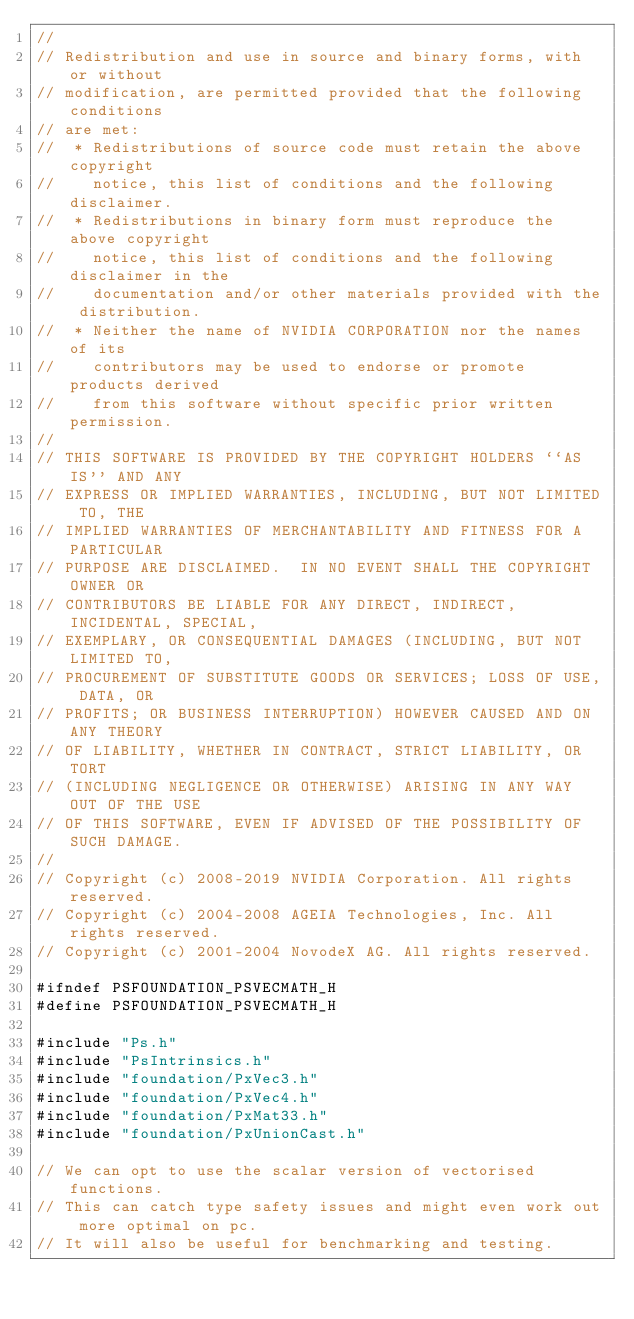Convert code to text. <code><loc_0><loc_0><loc_500><loc_500><_C_>//
// Redistribution and use in source and binary forms, with or without
// modification, are permitted provided that the following conditions
// are met:
//  * Redistributions of source code must retain the above copyright
//    notice, this list of conditions and the following disclaimer.
//  * Redistributions in binary form must reproduce the above copyright
//    notice, this list of conditions and the following disclaimer in the
//    documentation and/or other materials provided with the distribution.
//  * Neither the name of NVIDIA CORPORATION nor the names of its
//    contributors may be used to endorse or promote products derived
//    from this software without specific prior written permission.
//
// THIS SOFTWARE IS PROVIDED BY THE COPYRIGHT HOLDERS ``AS IS'' AND ANY
// EXPRESS OR IMPLIED WARRANTIES, INCLUDING, BUT NOT LIMITED TO, THE
// IMPLIED WARRANTIES OF MERCHANTABILITY AND FITNESS FOR A PARTICULAR
// PURPOSE ARE DISCLAIMED.  IN NO EVENT SHALL THE COPYRIGHT OWNER OR
// CONTRIBUTORS BE LIABLE FOR ANY DIRECT, INDIRECT, INCIDENTAL, SPECIAL,
// EXEMPLARY, OR CONSEQUENTIAL DAMAGES (INCLUDING, BUT NOT LIMITED TO,
// PROCUREMENT OF SUBSTITUTE GOODS OR SERVICES; LOSS OF USE, DATA, OR
// PROFITS; OR BUSINESS INTERRUPTION) HOWEVER CAUSED AND ON ANY THEORY
// OF LIABILITY, WHETHER IN CONTRACT, STRICT LIABILITY, OR TORT
// (INCLUDING NEGLIGENCE OR OTHERWISE) ARISING IN ANY WAY OUT OF THE USE
// OF THIS SOFTWARE, EVEN IF ADVISED OF THE POSSIBILITY OF SUCH DAMAGE.
//
// Copyright (c) 2008-2019 NVIDIA Corporation. All rights reserved.
// Copyright (c) 2004-2008 AGEIA Technologies, Inc. All rights reserved.
// Copyright (c) 2001-2004 NovodeX AG. All rights reserved.

#ifndef PSFOUNDATION_PSVECMATH_H
#define PSFOUNDATION_PSVECMATH_H

#include "Ps.h"
#include "PsIntrinsics.h"
#include "foundation/PxVec3.h"
#include "foundation/PxVec4.h"
#include "foundation/PxMat33.h"
#include "foundation/PxUnionCast.h"

// We can opt to use the scalar version of vectorised functions.
// This can catch type safety issues and might even work out more optimal on pc.
// It will also be useful for benchmarking and testing.</code> 